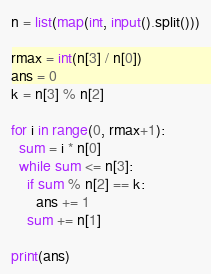<code> <loc_0><loc_0><loc_500><loc_500><_Python_>n = list(map(int, input().split()))

rmax = int(n[3] / n[0])
ans = 0
k = n[3] % n[2]

for i in range(0, rmax+1):
  sum = i * n[0]
  while sum <= n[3]:
    if sum % n[2] == k:
      ans += 1
    sum += n[1]

print(ans)

</code> 